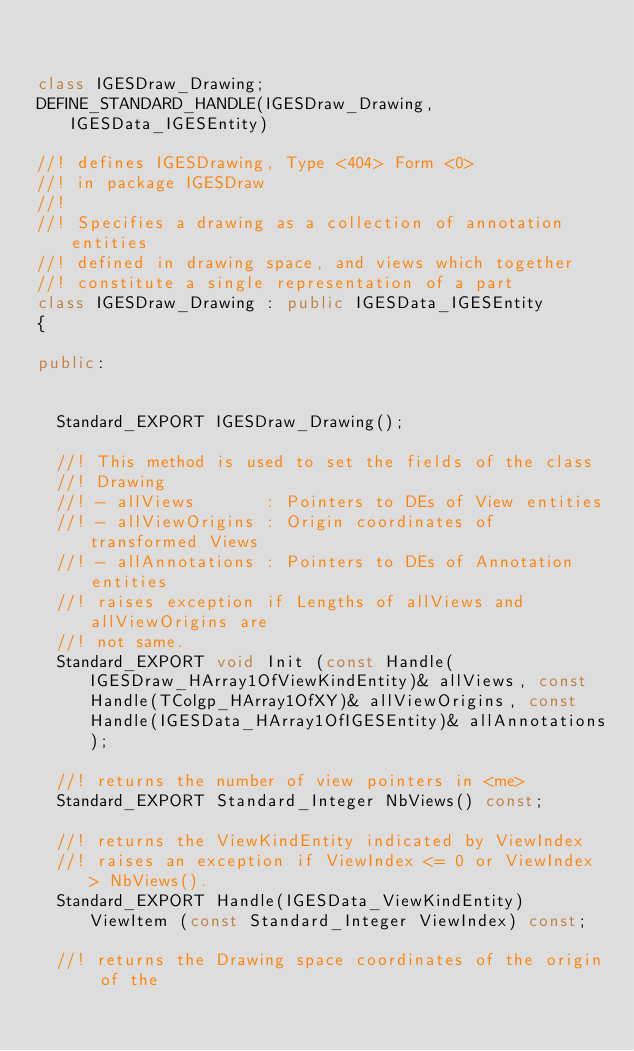<code> <loc_0><loc_0><loc_500><loc_500><_C++_>

class IGESDraw_Drawing;
DEFINE_STANDARD_HANDLE(IGESDraw_Drawing, IGESData_IGESEntity)

//! defines IGESDrawing, Type <404> Form <0>
//! in package IGESDraw
//!
//! Specifies a drawing as a collection of annotation entities
//! defined in drawing space, and views which together
//! constitute a single representation of a part
class IGESDraw_Drawing : public IGESData_IGESEntity
{

public:

  
  Standard_EXPORT IGESDraw_Drawing();
  
  //! This method is used to set the fields of the class
  //! Drawing
  //! - allViews       : Pointers to DEs of View entities
  //! - allViewOrigins : Origin coordinates of transformed Views
  //! - allAnnotations : Pointers to DEs of Annotation entities
  //! raises exception if Lengths of allViews and allViewOrigins are
  //! not same.
  Standard_EXPORT void Init (const Handle(IGESDraw_HArray1OfViewKindEntity)& allViews, const Handle(TColgp_HArray1OfXY)& allViewOrigins, const Handle(IGESData_HArray1OfIGESEntity)& allAnnotations);
  
  //! returns the number of view pointers in <me>
  Standard_EXPORT Standard_Integer NbViews() const;
  
  //! returns the ViewKindEntity indicated by ViewIndex
  //! raises an exception if ViewIndex <= 0 or ViewIndex > NbViews().
  Standard_EXPORT Handle(IGESData_ViewKindEntity) ViewItem (const Standard_Integer ViewIndex) const;
  
  //! returns the Drawing space coordinates of the origin of the</code> 